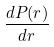Convert formula to latex. <formula><loc_0><loc_0><loc_500><loc_500>\frac { d P ( r ) } { d r }</formula> 